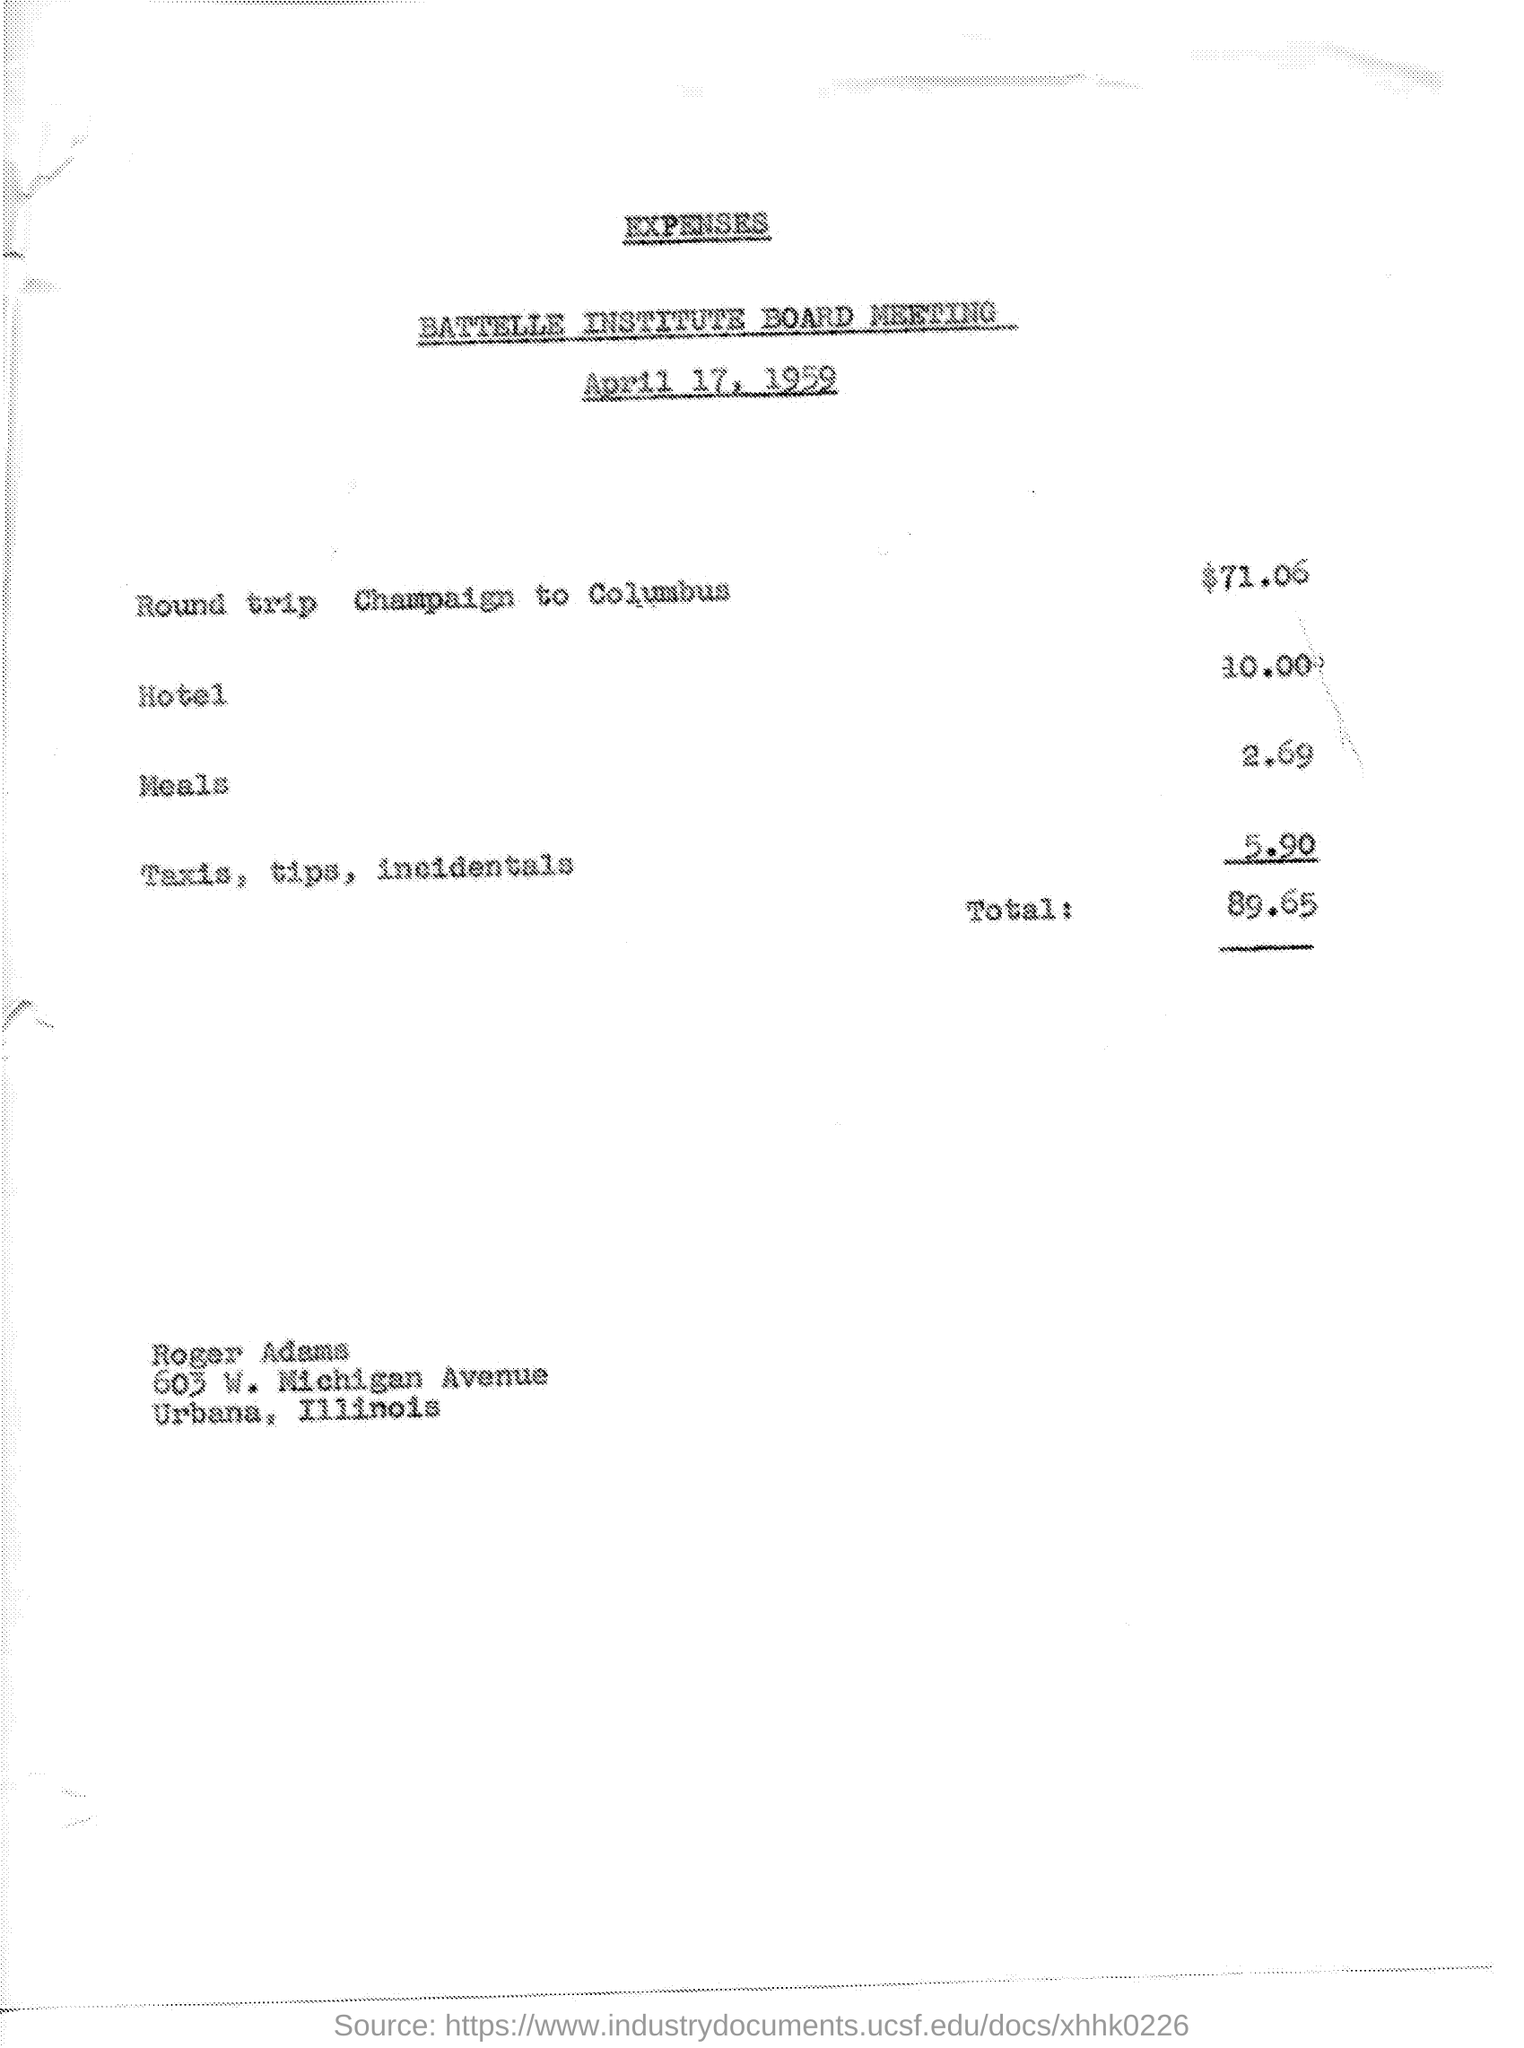Highlight a few significant elements in this photo. The title of the document is 'expenses.' The total amount is 89.65 dollars. The document is dated April 17, 1959 The cost of a round trip from Champaign to Columbus is $71.06. 